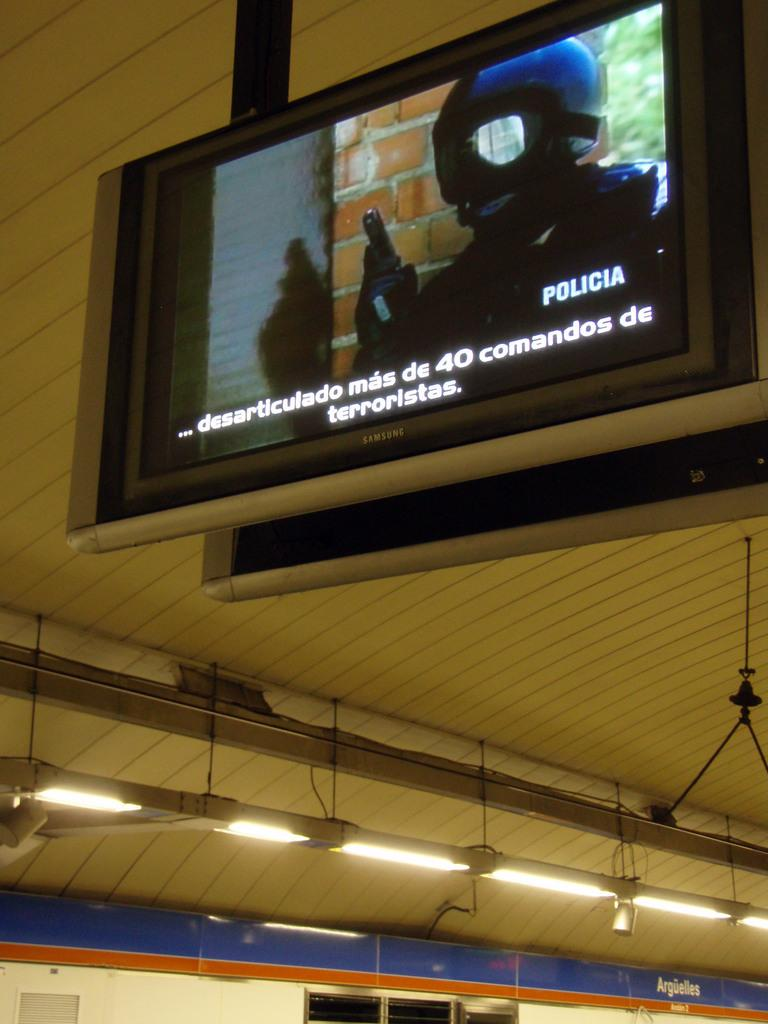What is the main object in the image? There is a screen in the image. What can be seen on the screen? The screen displays a man wearing a helmet. What is the man holding in the image? The man is holding a pistol in the image. What else is visible in the image besides the screen? There are lights and a wall visible in the image. What type of oranges are being sold in the alley next to the wall in the image? There are no oranges or alley present in the image; it only features a screen, lights, and a wall. 